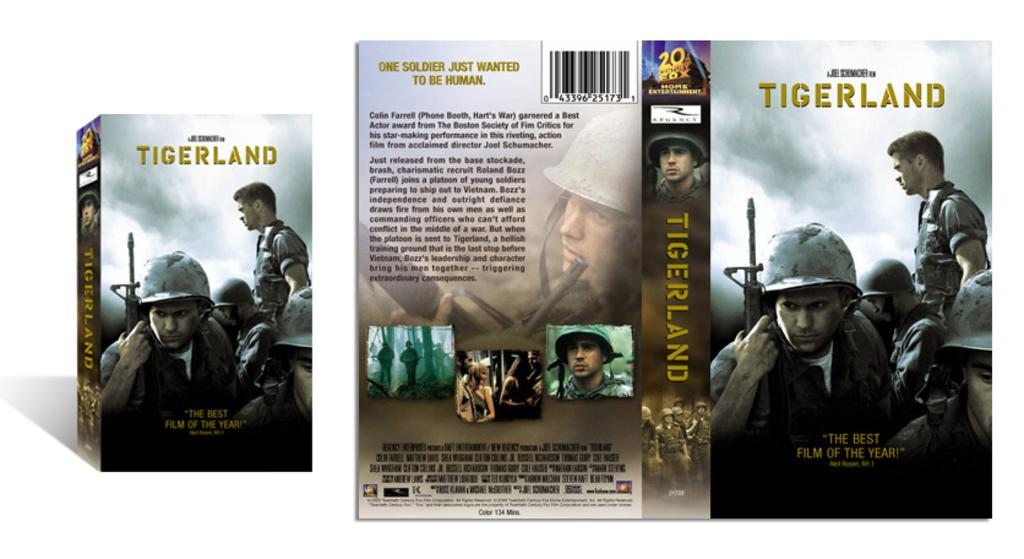What is written on the cover page in the image? The cover page has 'tiger land' written on it. What else can be seen on the cover page? There are people depicted on the cover page. What is the color of the background on the cover page? The background of the cover page is white. What is the taste of the salt depicted on the cover page? There is no salt depicted on the cover page; it only features the text 'tiger land' and people. 